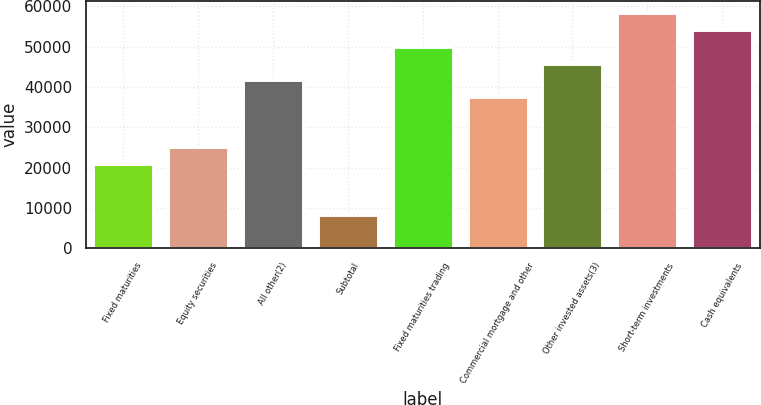Convert chart to OTSL. <chart><loc_0><loc_0><loc_500><loc_500><bar_chart><fcel>Fixed maturities<fcel>Equity securities<fcel>All other(2)<fcel>Subtotal<fcel>Fixed maturities trading<fcel>Commercial mortgage and other<fcel>Other invested assets(3)<fcel>Short-term investments<fcel>Cash equivalents<nl><fcel>20816.6<fcel>24979.9<fcel>41633<fcel>8326.83<fcel>49959.5<fcel>37469.7<fcel>45796.3<fcel>58286.1<fcel>54122.8<nl></chart> 